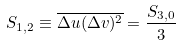Convert formula to latex. <formula><loc_0><loc_0><loc_500><loc_500>S _ { 1 , 2 } \equiv \overline { \Delta u ( \Delta v ) ^ { 2 } } = \frac { S _ { 3 , 0 } } { 3 }</formula> 